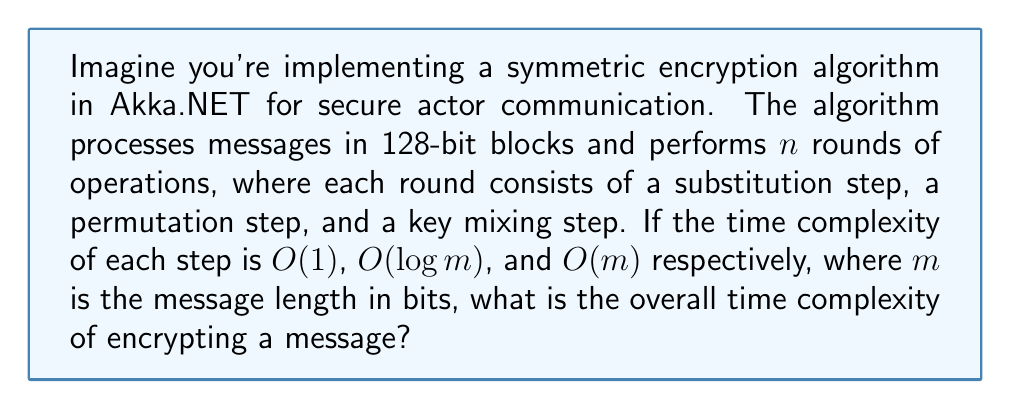Can you answer this question? Let's break this down step-by-step:

1) First, we need to consider how many blocks we'll process:
   - Message length: $m$ bits
   - Block size: 128 bits
   - Number of blocks: $\lceil \frac{m}{128} \rceil$

2) For each block, we perform $n$ rounds, and each round consists of three steps:
   - Substitution: $O(1)$
   - Permutation: $O(\log 128) = O(7) = O(1)$ (since 128 is constant)
   - Key mixing: $O(128) = O(1)$ (since 128 is constant)

3) The time complexity for processing one block is:
   $$O(n \cdot (1 + 1 + 1)) = O(n)$$

4) For the entire message, we repeat this for each block:
   $$O(n \cdot \lceil \frac{m}{128} \rceil) = O(n \cdot \frac{m}{128}) = O(nm)$$

5) Therefore, the overall time complexity is $O(nm)$, where $n$ is the number of rounds and $m$ is the message length in bits.
Answer: $O(nm)$ 